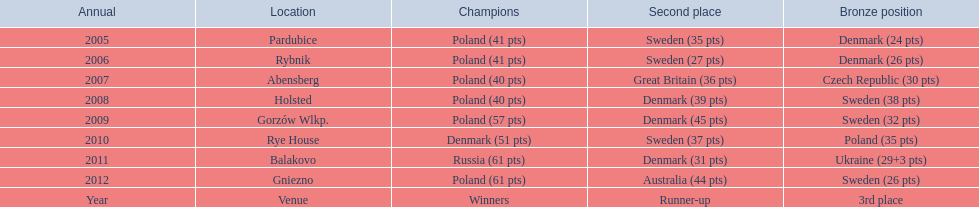In what years did denmark place in the top 3 in the team speedway junior world championship? 2005, 2006, 2008, 2009, 2010, 2011. What in what year did denmark come withing 2 points of placing higher in the standings? 2006. What place did denmark receive the year they missed higher ranking by only 2 points? 3rd place. 